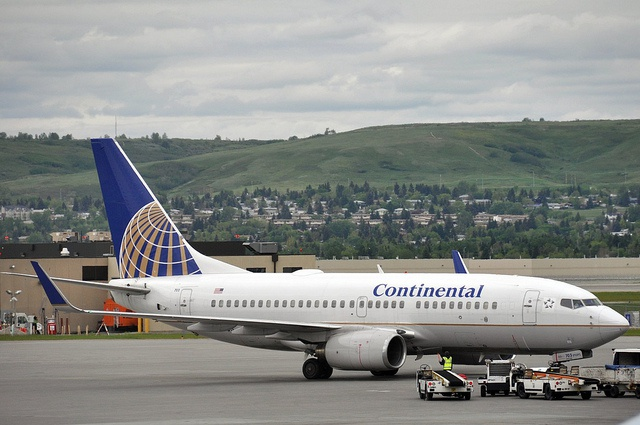Describe the objects in this image and their specific colors. I can see airplane in darkgray, lightgray, gray, and black tones, truck in darkgray, black, gray, and lightgray tones, truck in darkgray, black, and gray tones, truck in darkgray, black, gray, and lightgray tones, and people in darkgray, black, yellow, olive, and darkgreen tones in this image. 